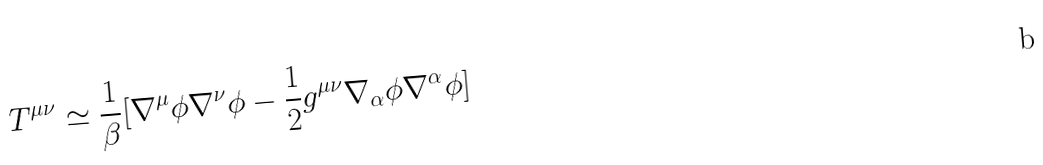<formula> <loc_0><loc_0><loc_500><loc_500>T ^ { \mu \nu } \simeq \frac { 1 } { \beta } [ \nabla ^ { \mu } \phi \nabla ^ { \nu } \phi - \frac { 1 } { 2 } g ^ { \mu \nu } \nabla _ { \alpha } \phi \nabla ^ { \alpha } \phi ]</formula> 